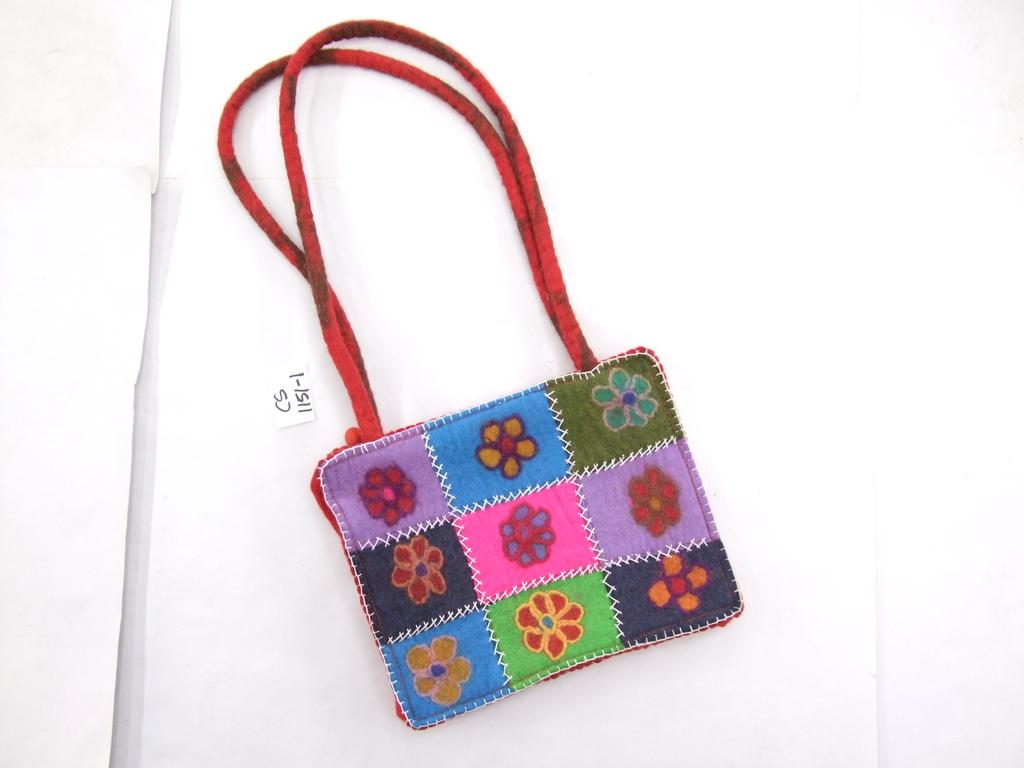What object in the image has flowers on it? There is a bag in the image, and it has flowers on it. What colors are the flowers on the bag? The flowers on the bag are blue, yellow, green, and black. How many quartz crystals can be seen in the image? There are no quartz crystals present in the image. What type of bird is sitting on the bag in the image? There is no bird, such as a crow, present in the image. 